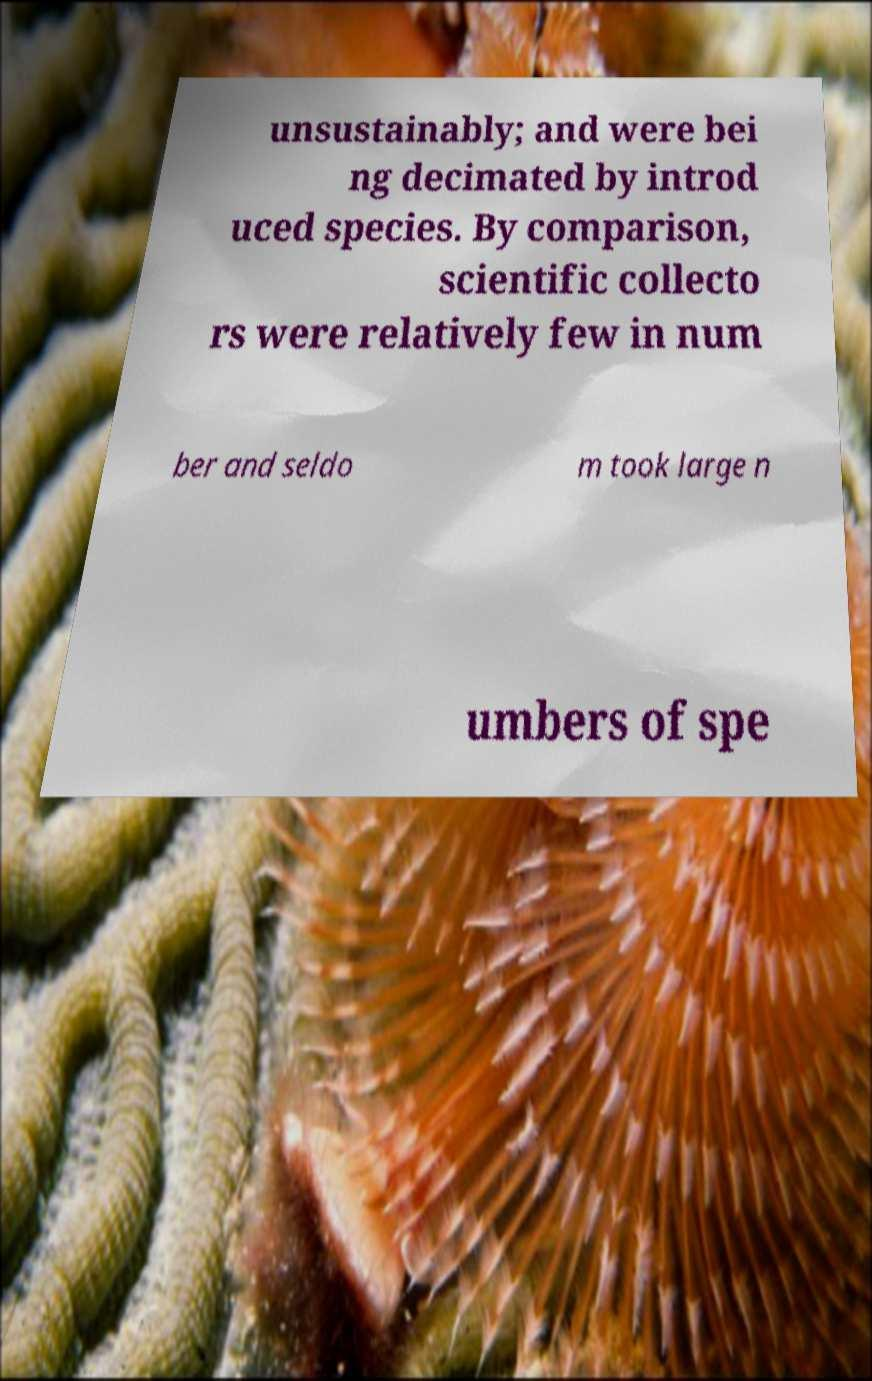Please identify and transcribe the text found in this image. unsustainably; and were bei ng decimated by introd uced species. By comparison, scientific collecto rs were relatively few in num ber and seldo m took large n umbers of spe 